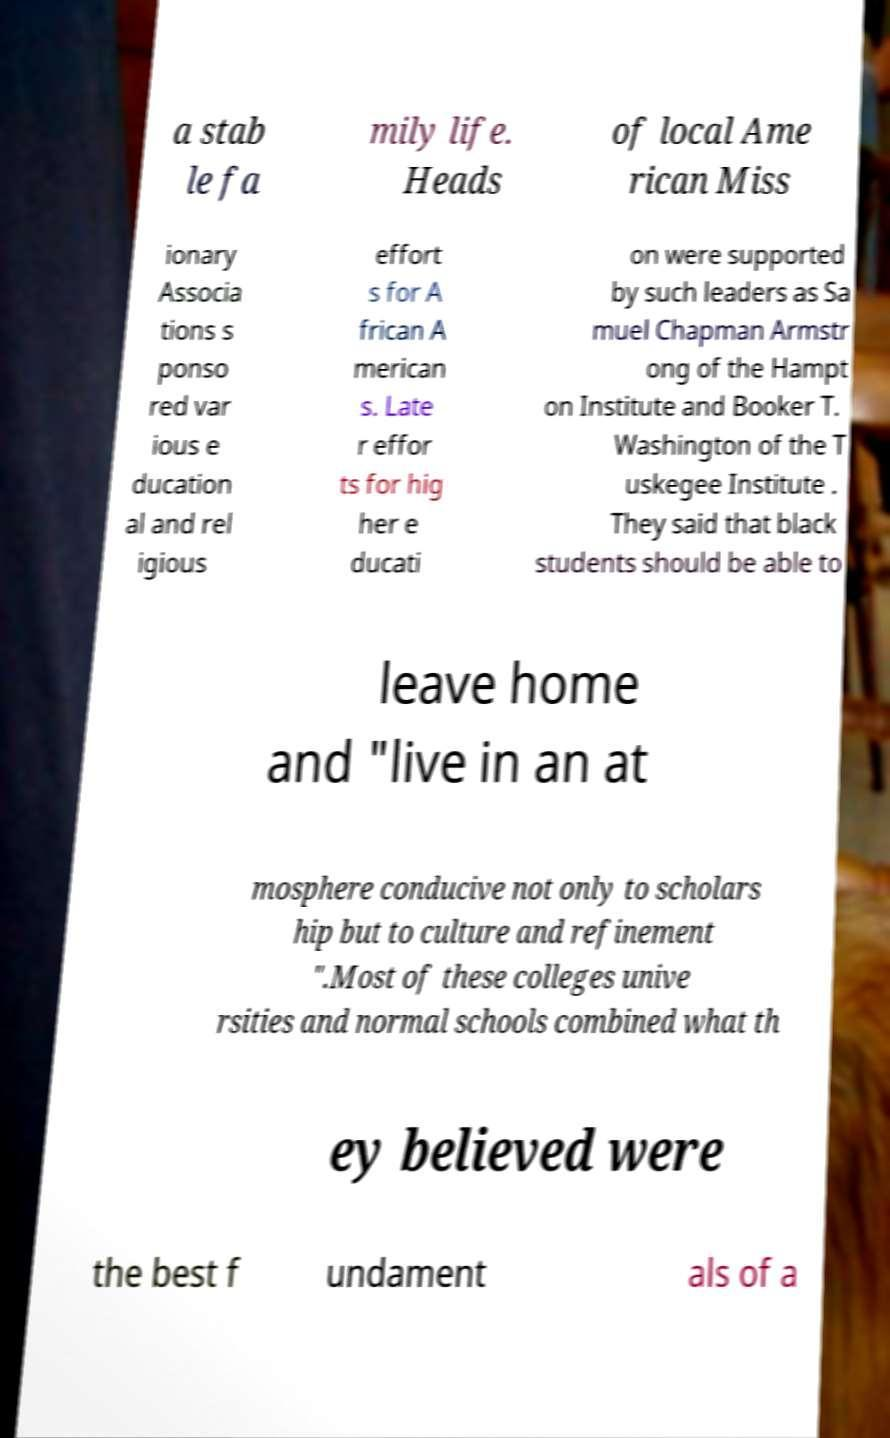Could you assist in decoding the text presented in this image and type it out clearly? a stab le fa mily life. Heads of local Ame rican Miss ionary Associa tions s ponso red var ious e ducation al and rel igious effort s for A frican A merican s. Late r effor ts for hig her e ducati on were supported by such leaders as Sa muel Chapman Armstr ong of the Hampt on Institute and Booker T. Washington of the T uskegee Institute . They said that black students should be able to leave home and "live in an at mosphere conducive not only to scholars hip but to culture and refinement ".Most of these colleges unive rsities and normal schools combined what th ey believed were the best f undament als of a 